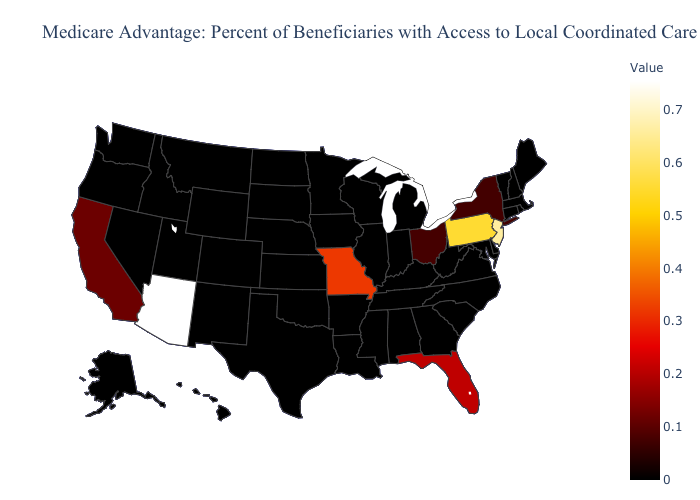Among the states that border Washington , which have the highest value?
Write a very short answer. Idaho, Oregon. Which states have the lowest value in the MidWest?
Write a very short answer. Iowa, Illinois, Indiana, Kansas, Michigan, Minnesota, North Dakota, Nebraska, South Dakota, Wisconsin. Does New Mexico have a lower value than California?
Write a very short answer. Yes. Which states hav the highest value in the Northeast?
Keep it brief. New Jersey. Among the states that border Arkansas , which have the lowest value?
Write a very short answer. Louisiana, Mississippi, Oklahoma, Tennessee, Texas. Is the legend a continuous bar?
Be succinct. Yes. Among the states that border Vermont , does New York have the highest value?
Answer briefly. Yes. Is the legend a continuous bar?
Keep it brief. Yes. Does Arizona have the highest value in the West?
Write a very short answer. Yes. 